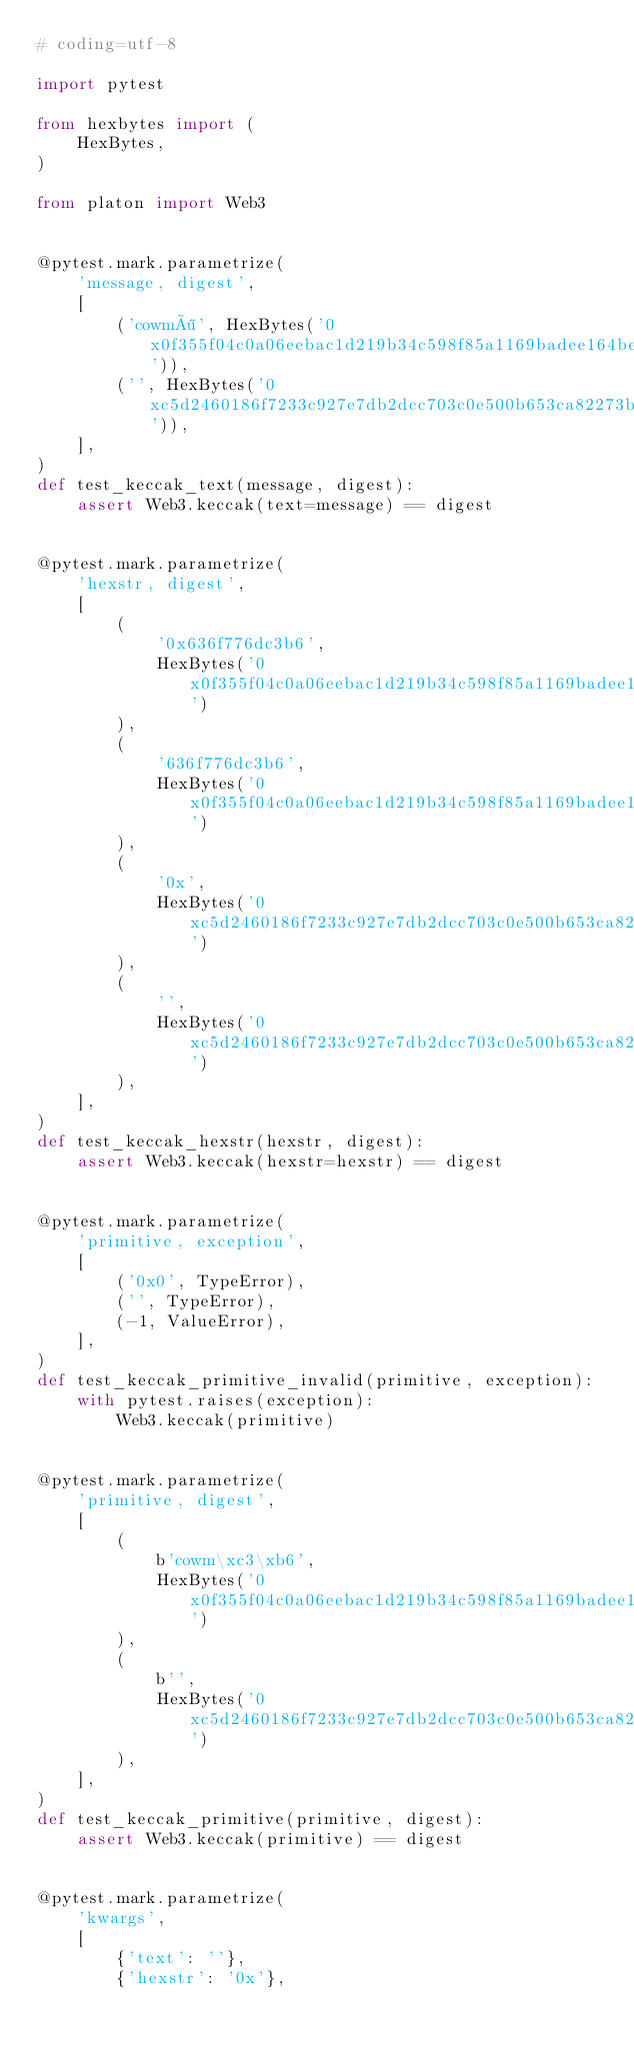Convert code to text. <code><loc_0><loc_0><loc_500><loc_500><_Python_># coding=utf-8

import pytest

from hexbytes import (
    HexBytes,
)

from platon import Web3


@pytest.mark.parametrize(
    'message, digest',
    [
        ('cowmö', HexBytes('0x0f355f04c0a06eebac1d219b34c598f85a1169badee164be8a30345944885fe8')),
        ('', HexBytes('0xc5d2460186f7233c927e7db2dcc703c0e500b653ca82273b7bfad8045d85a470')),
    ],
)
def test_keccak_text(message, digest):
    assert Web3.keccak(text=message) == digest


@pytest.mark.parametrize(
    'hexstr, digest',
    [
        (
            '0x636f776dc3b6',
            HexBytes('0x0f355f04c0a06eebac1d219b34c598f85a1169badee164be8a30345944885fe8')
        ),
        (
            '636f776dc3b6',
            HexBytes('0x0f355f04c0a06eebac1d219b34c598f85a1169badee164be8a30345944885fe8')
        ),
        (
            '0x',
            HexBytes('0xc5d2460186f7233c927e7db2dcc703c0e500b653ca82273b7bfad8045d85a470')
        ),
        (
            '',
            HexBytes('0xc5d2460186f7233c927e7db2dcc703c0e500b653ca82273b7bfad8045d85a470')
        ),
    ],
)
def test_keccak_hexstr(hexstr, digest):
    assert Web3.keccak(hexstr=hexstr) == digest


@pytest.mark.parametrize(
    'primitive, exception',
    [
        ('0x0', TypeError),
        ('', TypeError),
        (-1, ValueError),
    ],
)
def test_keccak_primitive_invalid(primitive, exception):
    with pytest.raises(exception):
        Web3.keccak(primitive)


@pytest.mark.parametrize(
    'primitive, digest',
    [
        (
            b'cowm\xc3\xb6',
            HexBytes('0x0f355f04c0a06eebac1d219b34c598f85a1169badee164be8a30345944885fe8')
        ),
        (
            b'',
            HexBytes('0xc5d2460186f7233c927e7db2dcc703c0e500b653ca82273b7bfad8045d85a470')
        ),
    ],
)
def test_keccak_primitive(primitive, digest):
    assert Web3.keccak(primitive) == digest


@pytest.mark.parametrize(
    'kwargs',
    [
        {'text': ''},
        {'hexstr': '0x'},</code> 